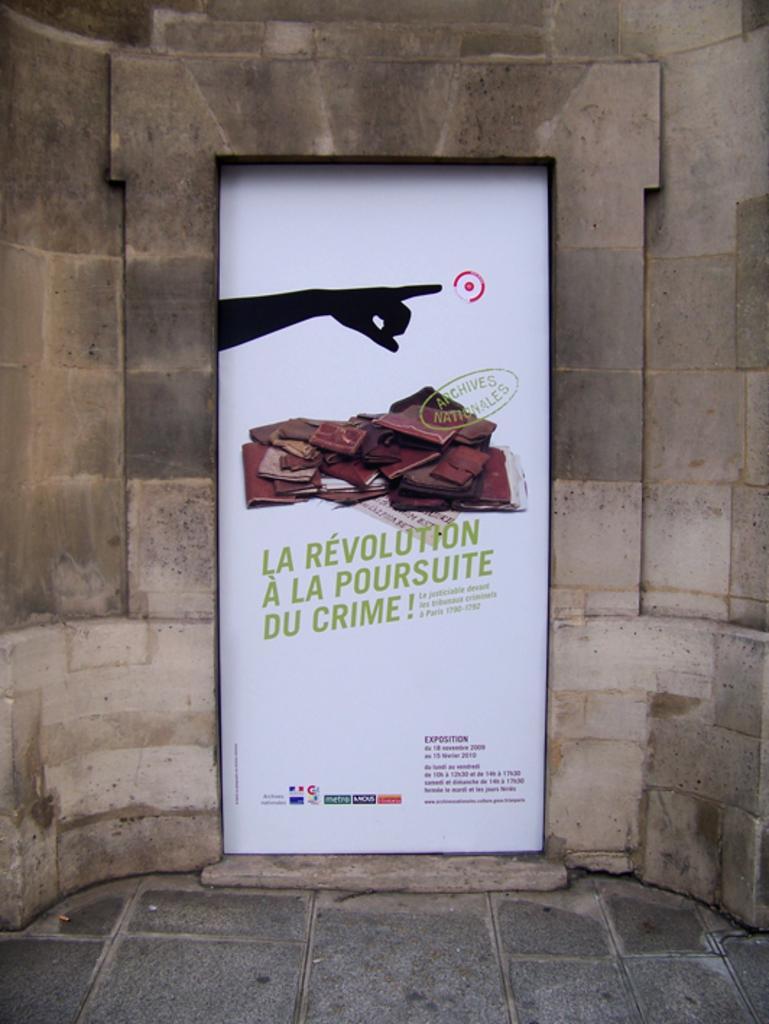Could you give a brief overview of what you see in this image? In this image, we can see a white color poster, on that poster we can see a hand of a person and we can see a wall. 